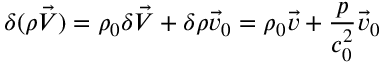Convert formula to latex. <formula><loc_0><loc_0><loc_500><loc_500>\delta ( \rho \vec { V } ) = \rho _ { 0 } \delta \vec { V } + \delta \rho \vec { v } _ { 0 } = \rho _ { 0 } \vec { v } + \frac { p } { c _ { 0 } ^ { 2 } } \vec { v } _ { 0 }</formula> 